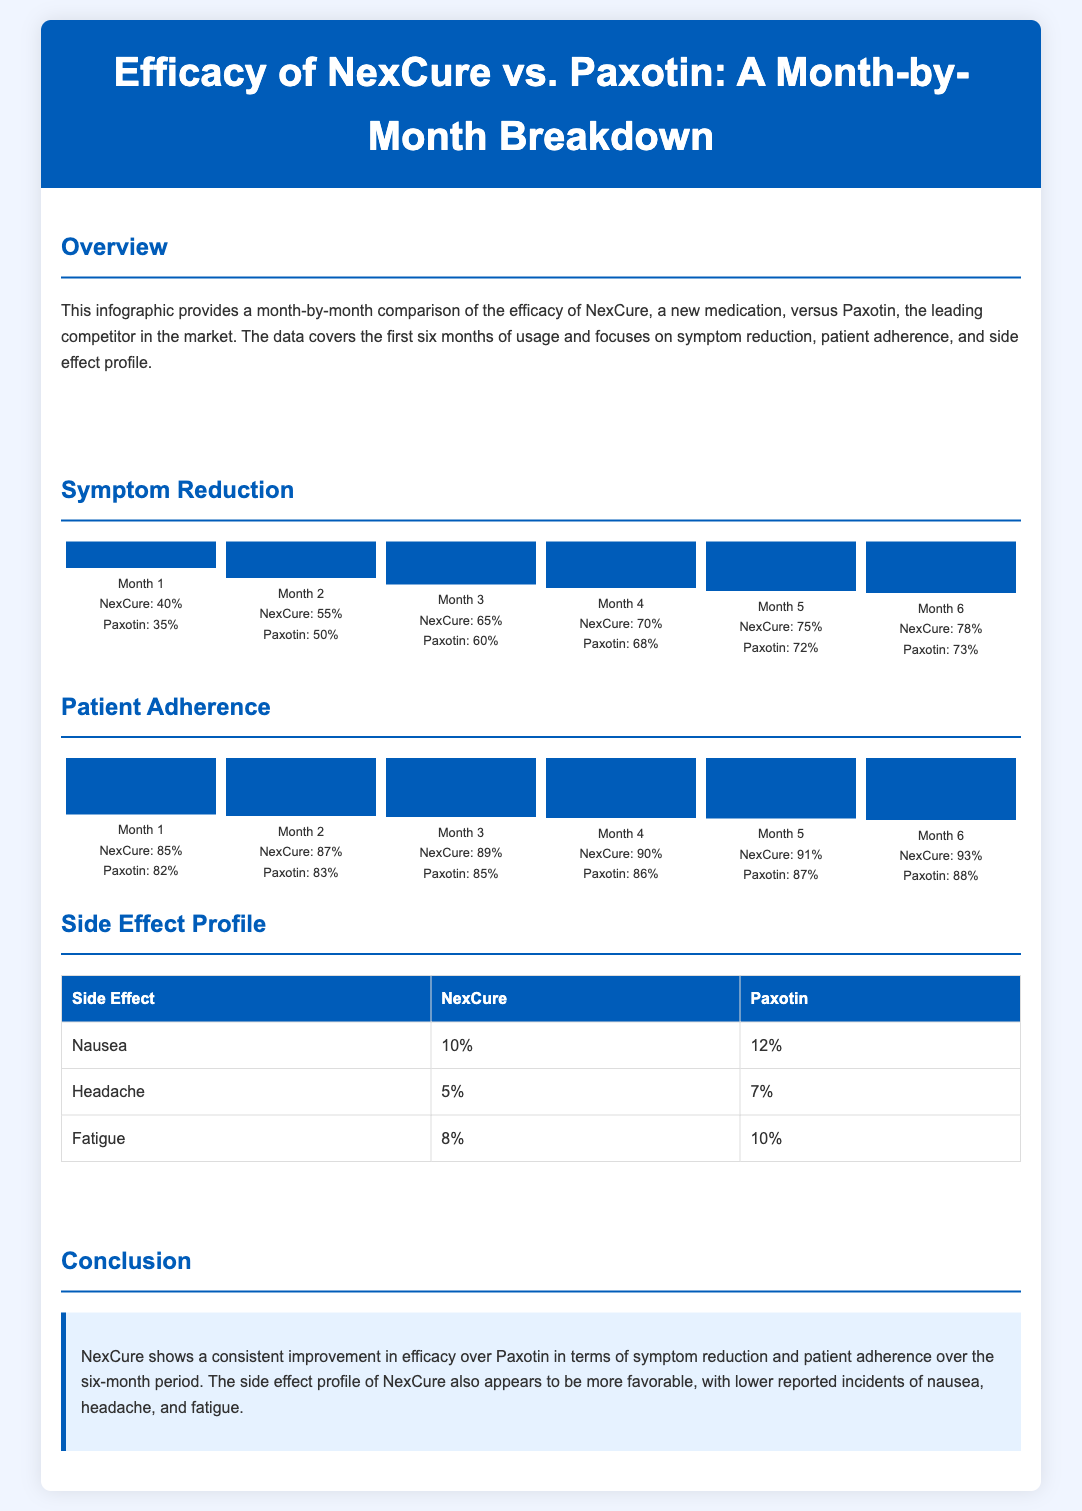what was the efficacy of NexCure in Month 1? The efficacy of NexCure in Month 1 is indicated in the chart section where it shows a symptom reduction of 40%.
Answer: 40% what was the percentage of patient adherence for Paxotin in Month 6? The patient adherence for Paxotin in Month 6 can be found in the chart section, which shows 88%.
Answer: 88% how much did NexCure improve in symptom reduction from Month 1 to Month 6? To find out how much NexCure improved, we can subtract the Month 1 percentage from the Month 6 percentage, which is 78% - 40% = 38%.
Answer: 38% which medication had a lower incidence of nausea? The side effect profile table reveals that NexCure has a lower incidence of nausea compared to Paxotin, with 10% versus 12%.
Answer: NexCure what was the side effect percentage for headache with Paxotin? The percentage for headaches with Paxotin is shown in the side effect profile table, where it lists 7%.
Answer: 7% in which month did NexCure have the highest patient adherence? The highest patient adherence for NexCure is during Month 6, as indicated by the chart section showing 93%.
Answer: Month 6 what is the main conclusion of the document? The conclusion section emphasizes that NexCure shows better efficacy and a more favorable side effect profile compared to Paxotin.
Answer: NexCure shows better efficacy what side effect had the highest percentage for NexCure? The side effect with the highest percentage for NexCure is nausea, listed at 10% in the side effect profile table.
Answer: Nausea which month showed the greatest improvement in symptom reduction for NexCure? By examining the chart, Month 6 shows the greatest improvement in symptom reduction for NexCure with 78%.
Answer: Month 6 